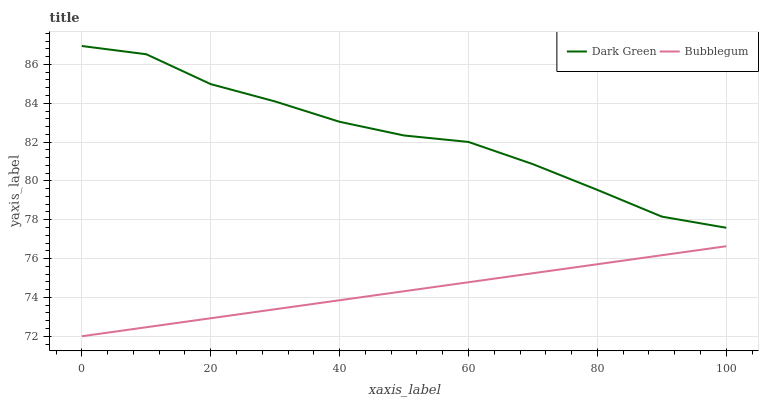Does Bubblegum have the minimum area under the curve?
Answer yes or no. Yes. Does Dark Green have the maximum area under the curve?
Answer yes or no. Yes. Does Dark Green have the minimum area under the curve?
Answer yes or no. No. Is Bubblegum the smoothest?
Answer yes or no. Yes. Is Dark Green the roughest?
Answer yes or no. Yes. Is Dark Green the smoothest?
Answer yes or no. No. Does Bubblegum have the lowest value?
Answer yes or no. Yes. Does Dark Green have the lowest value?
Answer yes or no. No. Does Dark Green have the highest value?
Answer yes or no. Yes. Is Bubblegum less than Dark Green?
Answer yes or no. Yes. Is Dark Green greater than Bubblegum?
Answer yes or no. Yes. Does Bubblegum intersect Dark Green?
Answer yes or no. No. 